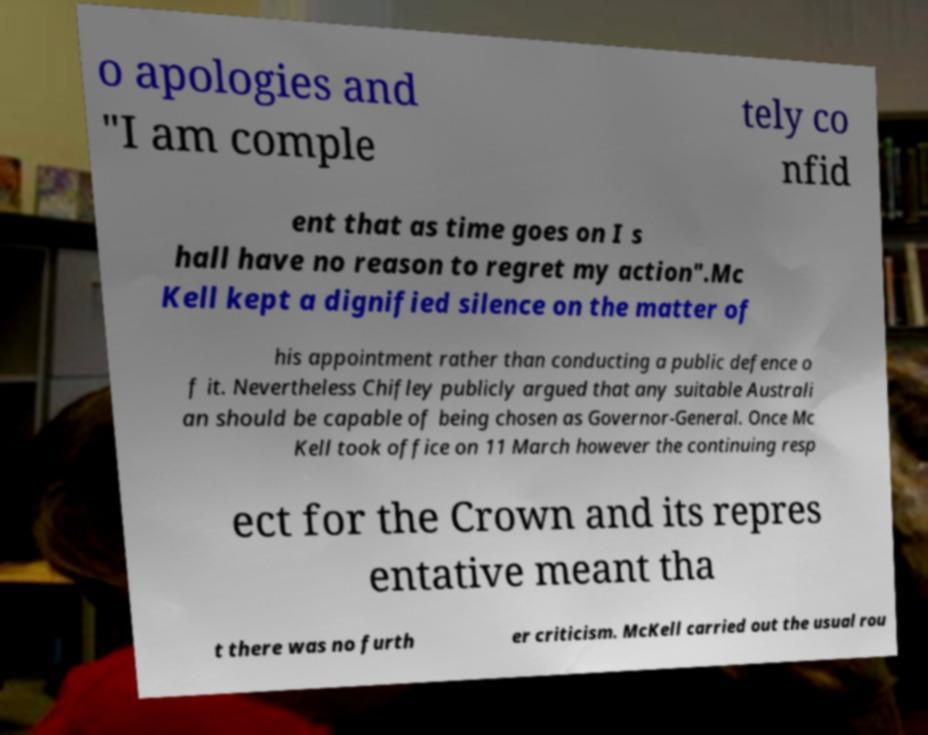What messages or text are displayed in this image? I need them in a readable, typed format. o apologies and "I am comple tely co nfid ent that as time goes on I s hall have no reason to regret my action".Mc Kell kept a dignified silence on the matter of his appointment rather than conducting a public defence o f it. Nevertheless Chifley publicly argued that any suitable Australi an should be capable of being chosen as Governor-General. Once Mc Kell took office on 11 March however the continuing resp ect for the Crown and its repres entative meant tha t there was no furth er criticism. McKell carried out the usual rou 